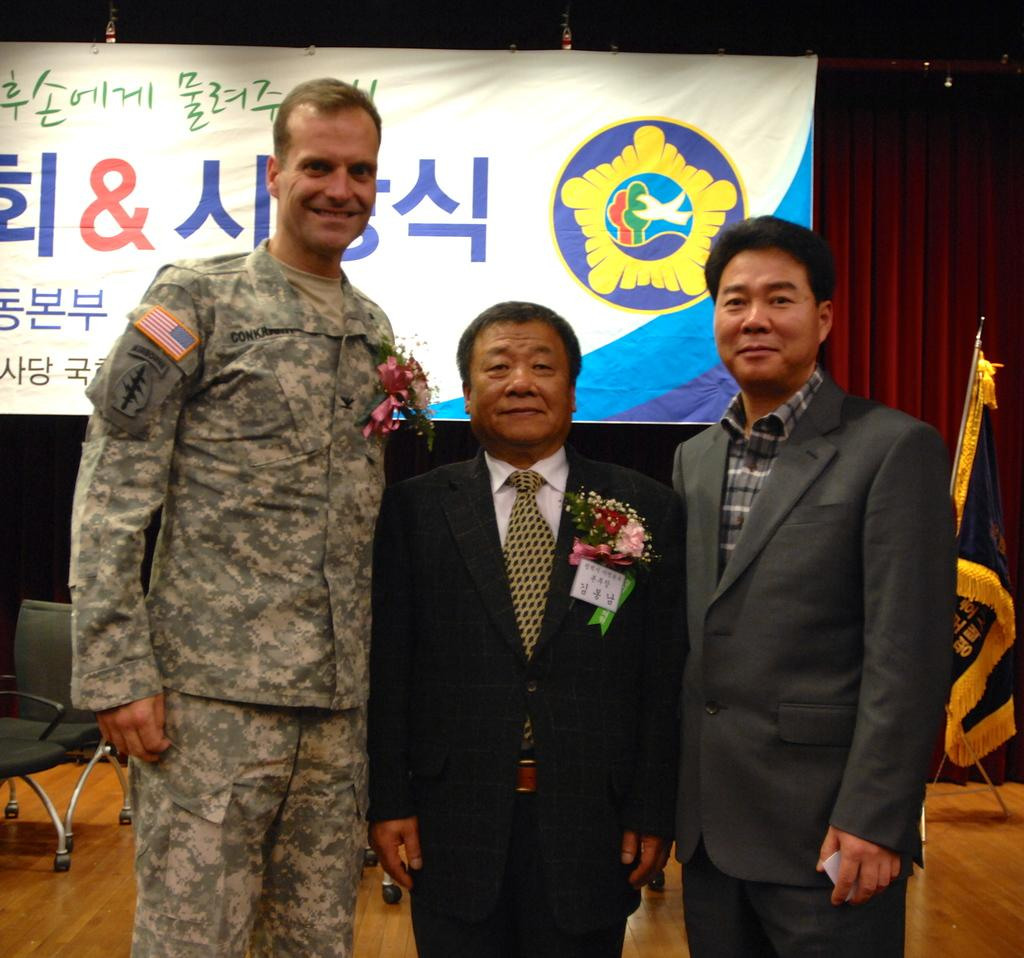What is happening in the image? There are people standing in the image. What can be seen in the background of the image? There is a chair and a poster in the background of the image. What type of competition is being held in the image? There is no competition present in the image; it simply shows people standing with a chair and a poster in the background. 